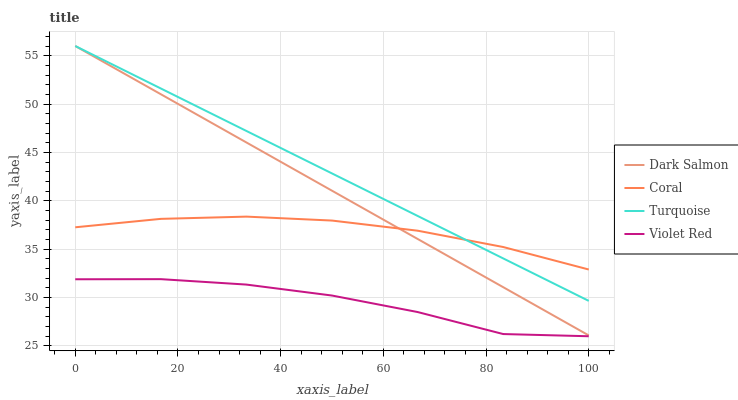Does Coral have the minimum area under the curve?
Answer yes or no. No. Does Coral have the maximum area under the curve?
Answer yes or no. No. Is Coral the smoothest?
Answer yes or no. No. Is Coral the roughest?
Answer yes or no. No. Does Turquoise have the lowest value?
Answer yes or no. No. Does Coral have the highest value?
Answer yes or no. No. Is Violet Red less than Turquoise?
Answer yes or no. Yes. Is Dark Salmon greater than Violet Red?
Answer yes or no. Yes. Does Violet Red intersect Turquoise?
Answer yes or no. No. 